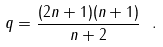Convert formula to latex. <formula><loc_0><loc_0><loc_500><loc_500>q = \frac { ( 2 n + 1 ) ( n + 1 ) } { n + 2 } \ .</formula> 